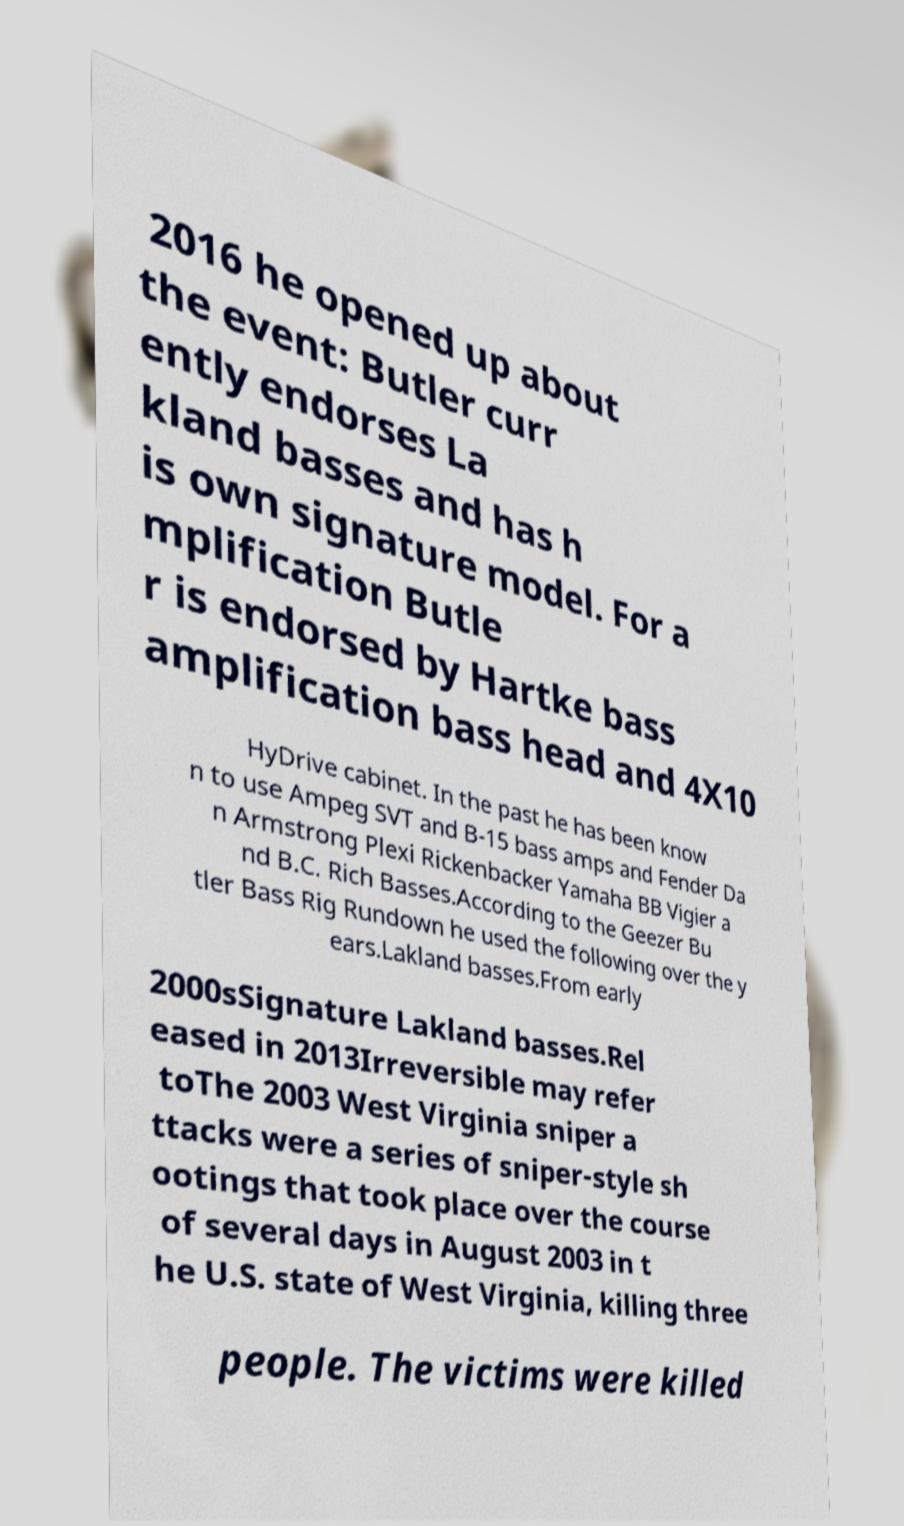I need the written content from this picture converted into text. Can you do that? 2016 he opened up about the event: Butler curr ently endorses La kland basses and has h is own signature model. For a mplification Butle r is endorsed by Hartke bass amplification bass head and 4X10 HyDrive cabinet. In the past he has been know n to use Ampeg SVT and B-15 bass amps and Fender Da n Armstrong Plexi Rickenbacker Yamaha BB Vigier a nd B.C. Rich Basses.According to the Geezer Bu tler Bass Rig Rundown he used the following over the y ears.Lakland basses.From early 2000sSignature Lakland basses.Rel eased in 2013Irreversible may refer toThe 2003 West Virginia sniper a ttacks were a series of sniper-style sh ootings that took place over the course of several days in August 2003 in t he U.S. state of West Virginia, killing three people. The victims were killed 